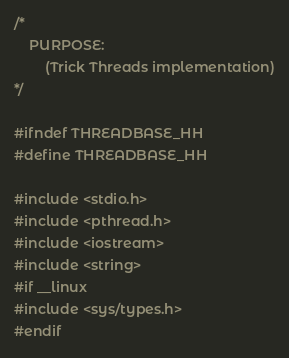Convert code to text. <code><loc_0><loc_0><loc_500><loc_500><_C++_>/*
    PURPOSE:
        (Trick Threads implementation)
*/

#ifndef THREADBASE_HH
#define THREADBASE_HH

#include <stdio.h>
#include <pthread.h>
#include <iostream>
#include <string>
#if __linux
#include <sys/types.h>
#endif</code> 